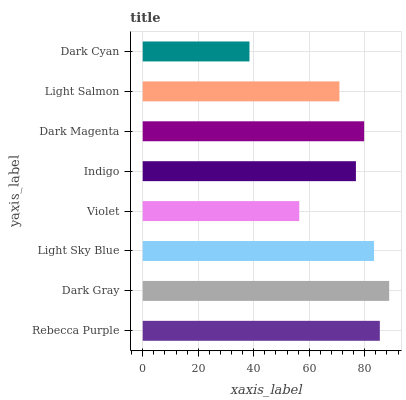Is Dark Cyan the minimum?
Answer yes or no. Yes. Is Dark Gray the maximum?
Answer yes or no. Yes. Is Light Sky Blue the minimum?
Answer yes or no. No. Is Light Sky Blue the maximum?
Answer yes or no. No. Is Dark Gray greater than Light Sky Blue?
Answer yes or no. Yes. Is Light Sky Blue less than Dark Gray?
Answer yes or no. Yes. Is Light Sky Blue greater than Dark Gray?
Answer yes or no. No. Is Dark Gray less than Light Sky Blue?
Answer yes or no. No. Is Dark Magenta the high median?
Answer yes or no. Yes. Is Indigo the low median?
Answer yes or no. Yes. Is Dark Gray the high median?
Answer yes or no. No. Is Light Sky Blue the low median?
Answer yes or no. No. 